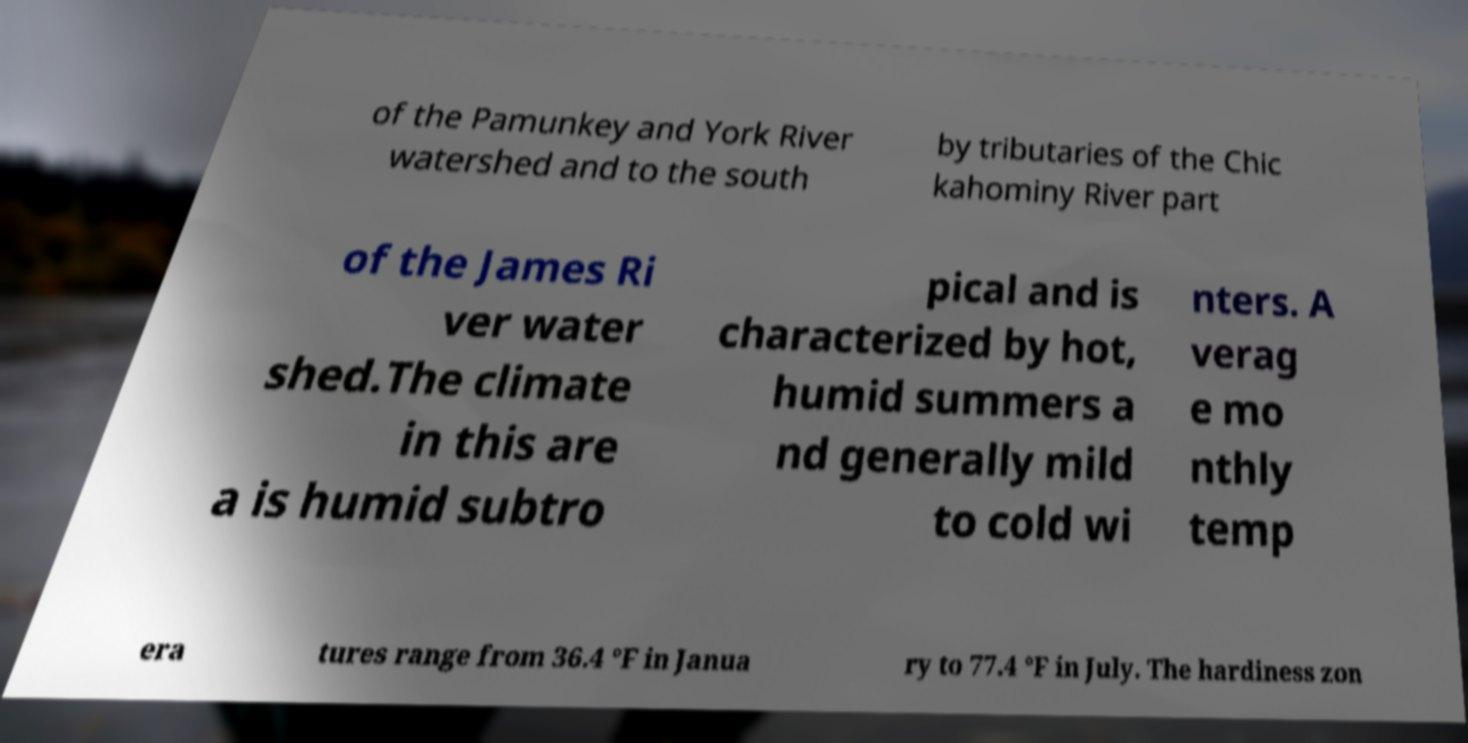Can you accurately transcribe the text from the provided image for me? of the Pamunkey and York River watershed and to the south by tributaries of the Chic kahominy River part of the James Ri ver water shed.The climate in this are a is humid subtro pical and is characterized by hot, humid summers a nd generally mild to cold wi nters. A verag e mo nthly temp era tures range from 36.4 °F in Janua ry to 77.4 °F in July. The hardiness zon 